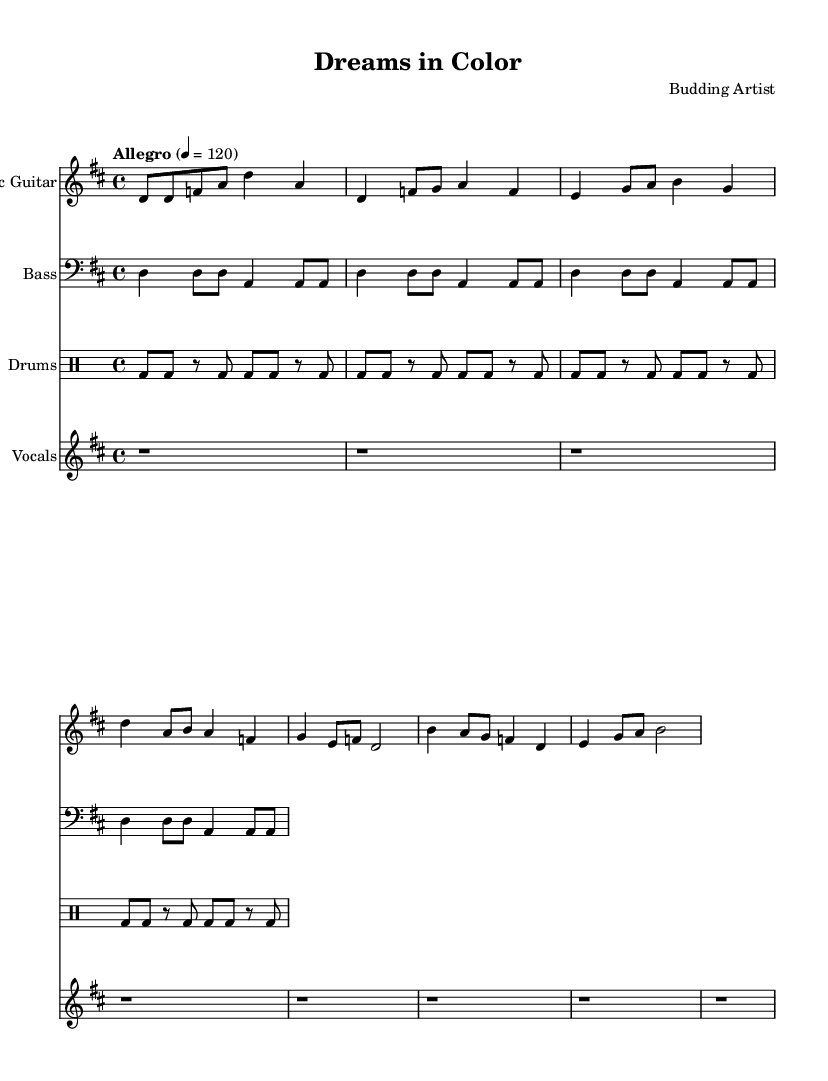What is the key signature of this music? The key signature is indicated by the number of sharps or flats at the beginning of the staff. In this case, it shows two sharps, which corresponds to D major.
Answer: D major What is the time signature of this music? The time signature is located at the beginning of the score and consists of two numbers; the top number indicates the number of beats per measure, while the bottom number indicates the note value that receives one beat. Here, the time signature is 4 over 4, meaning four beats per measure.
Answer: 4/4 What is the tempo marking of this music? The tempo marking is indicated in the score by the term "Allegro" followed by a number. "Allegro" means fast, and the number 120 indicates the beats per minute.
Answer: Allegro 4 = 120 How many sections does this song have? The music is structured into several distinct sections: the Intro, Verse, Chorus, and Bridge. By counting these sections from the provided music, you can establish that there are four primary sections.
Answer: Four What instrument plays the main melody in this piece? The main melody is usually carried by a specific instrument as indicated in the score. In this case, the Electric Guitar part mainly plays in the treble clef, which is typically where the melody is found.
Answer: Electric Guitar Which part includes lyrics? The lyrics are specifically written in the vocal part of the score, distinctly marked by the lyrics being associated with the vocal staff. This shows that the vocals carry the text for the melody.
Answer: Vocals What is the rhythm pattern for the drums? The drums are indicated in a separate staff where the notation symbols specifically show the rhythm pattern. The rhythm consists of bass drum strikes and rests. Analyzing the notations indicates a repeating pattern across measures.
Answer: Repeating bass drum pattern 